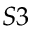Convert formula to latex. <formula><loc_0><loc_0><loc_500><loc_500>S 3</formula> 